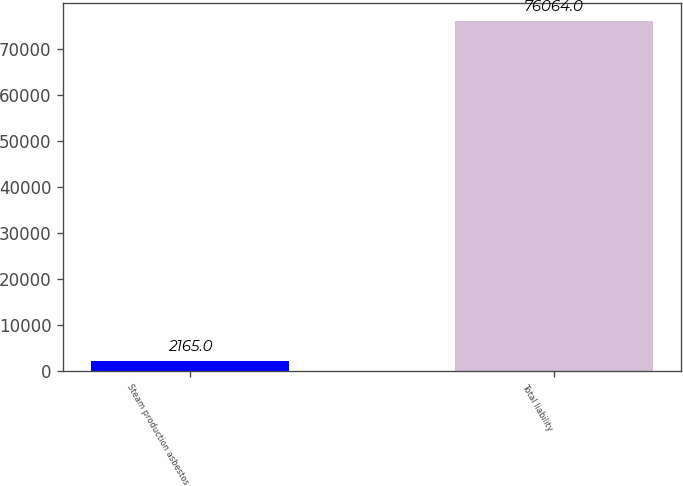Convert chart to OTSL. <chart><loc_0><loc_0><loc_500><loc_500><bar_chart><fcel>Steam production asbestos<fcel>Total liability<nl><fcel>2165<fcel>76064<nl></chart> 